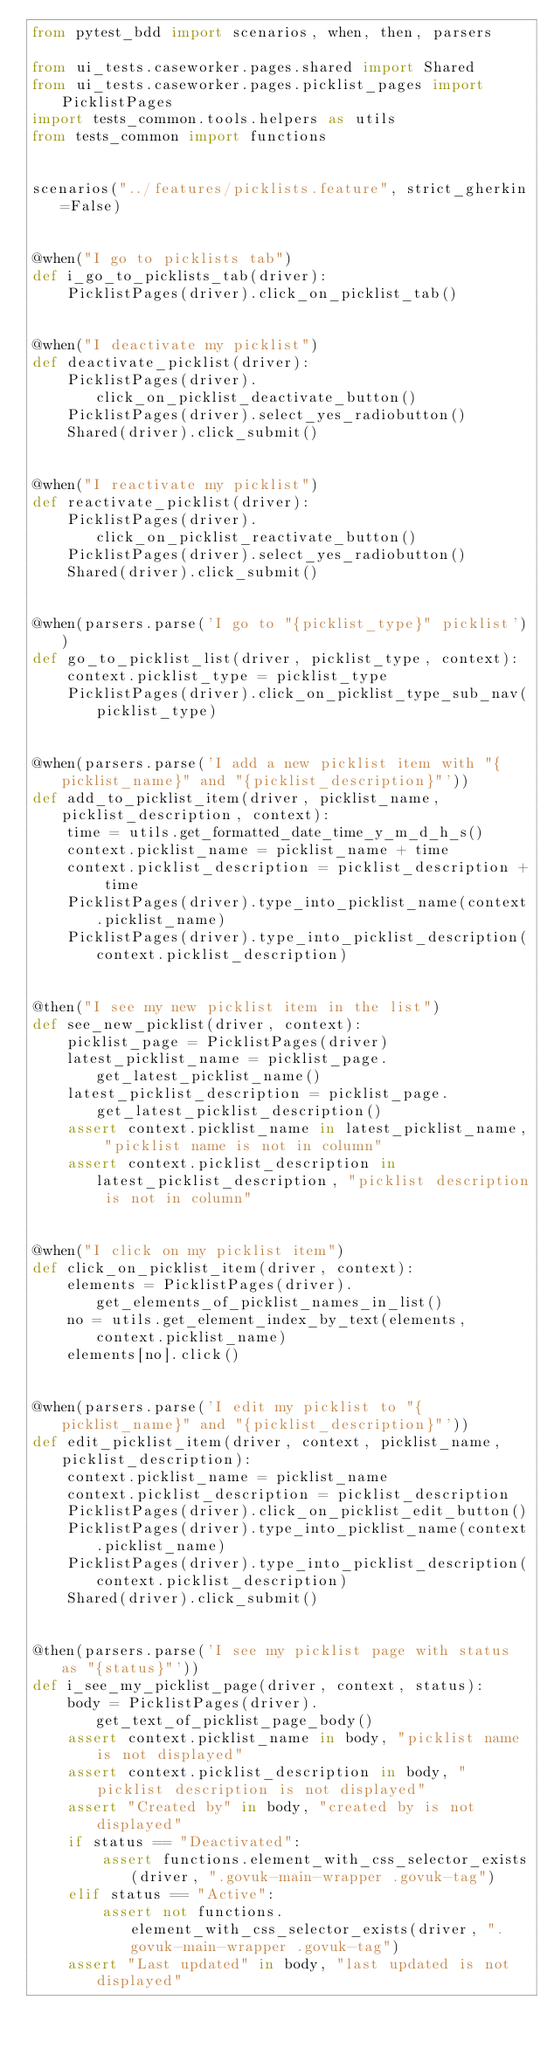<code> <loc_0><loc_0><loc_500><loc_500><_Python_>from pytest_bdd import scenarios, when, then, parsers

from ui_tests.caseworker.pages.shared import Shared
from ui_tests.caseworker.pages.picklist_pages import PicklistPages
import tests_common.tools.helpers as utils
from tests_common import functions


scenarios("../features/picklists.feature", strict_gherkin=False)


@when("I go to picklists tab")
def i_go_to_picklists_tab(driver):
    PicklistPages(driver).click_on_picklist_tab()


@when("I deactivate my picklist")
def deactivate_picklist(driver):
    PicklistPages(driver).click_on_picklist_deactivate_button()
    PicklistPages(driver).select_yes_radiobutton()
    Shared(driver).click_submit()


@when("I reactivate my picklist")
def reactivate_picklist(driver):
    PicklistPages(driver).click_on_picklist_reactivate_button()
    PicklistPages(driver).select_yes_radiobutton()
    Shared(driver).click_submit()


@when(parsers.parse('I go to "{picklist_type}" picklist'))
def go_to_picklist_list(driver, picklist_type, context):
    context.picklist_type = picklist_type
    PicklistPages(driver).click_on_picklist_type_sub_nav(picklist_type)


@when(parsers.parse('I add a new picklist item with "{picklist_name}" and "{picklist_description}"'))
def add_to_picklist_item(driver, picklist_name, picklist_description, context):
    time = utils.get_formatted_date_time_y_m_d_h_s()
    context.picklist_name = picklist_name + time
    context.picklist_description = picklist_description + time
    PicklistPages(driver).type_into_picklist_name(context.picklist_name)
    PicklistPages(driver).type_into_picklist_description(context.picklist_description)


@then("I see my new picklist item in the list")
def see_new_picklist(driver, context):
    picklist_page = PicklistPages(driver)
    latest_picklist_name = picklist_page.get_latest_picklist_name()
    latest_picklist_description = picklist_page.get_latest_picklist_description()
    assert context.picklist_name in latest_picklist_name, "picklist name is not in column"
    assert context.picklist_description in latest_picklist_description, "picklist description is not in column"


@when("I click on my picklist item")
def click_on_picklist_item(driver, context):
    elements = PicklistPages(driver).get_elements_of_picklist_names_in_list()
    no = utils.get_element_index_by_text(elements, context.picklist_name)
    elements[no].click()


@when(parsers.parse('I edit my picklist to "{picklist_name}" and "{picklist_description}"'))
def edit_picklist_item(driver, context, picklist_name, picklist_description):
    context.picklist_name = picklist_name
    context.picklist_description = picklist_description
    PicklistPages(driver).click_on_picklist_edit_button()
    PicklistPages(driver).type_into_picklist_name(context.picklist_name)
    PicklistPages(driver).type_into_picklist_description(context.picklist_description)
    Shared(driver).click_submit()


@then(parsers.parse('I see my picklist page with status as "{status}"'))
def i_see_my_picklist_page(driver, context, status):
    body = PicklistPages(driver).get_text_of_picklist_page_body()
    assert context.picklist_name in body, "picklist name is not displayed"
    assert context.picklist_description in body, "picklist description is not displayed"
    assert "Created by" in body, "created by is not displayed"
    if status == "Deactivated":
        assert functions.element_with_css_selector_exists(driver, ".govuk-main-wrapper .govuk-tag")
    elif status == "Active":
        assert not functions.element_with_css_selector_exists(driver, ".govuk-main-wrapper .govuk-tag")
    assert "Last updated" in body, "last updated is not displayed"</code> 